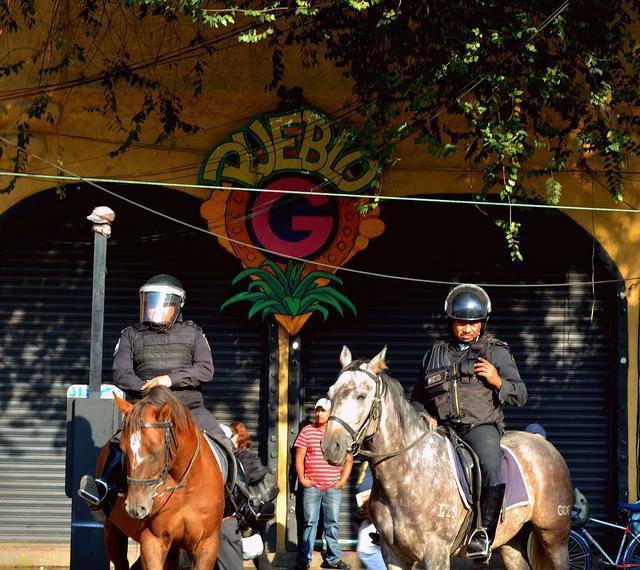How many people can you see?
Give a very brief answer. 3. How many horses can you see?
Give a very brief answer. 2. 